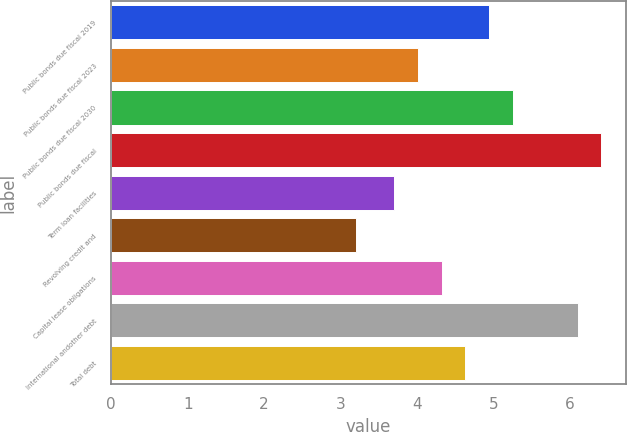<chart> <loc_0><loc_0><loc_500><loc_500><bar_chart><fcel>Public bonds due fiscal 2019<fcel>Public bonds due fiscal 2023<fcel>Public bonds due fiscal 2030<fcel>Public bonds due fiscal<fcel>Term loan facilities<fcel>Revolving credit and<fcel>Capital lease obligations<fcel>International andother debt<fcel>Total debt<nl><fcel>4.94<fcel>4.01<fcel>5.25<fcel>6.41<fcel>3.7<fcel>3.2<fcel>4.32<fcel>6.1<fcel>4.63<nl></chart> 